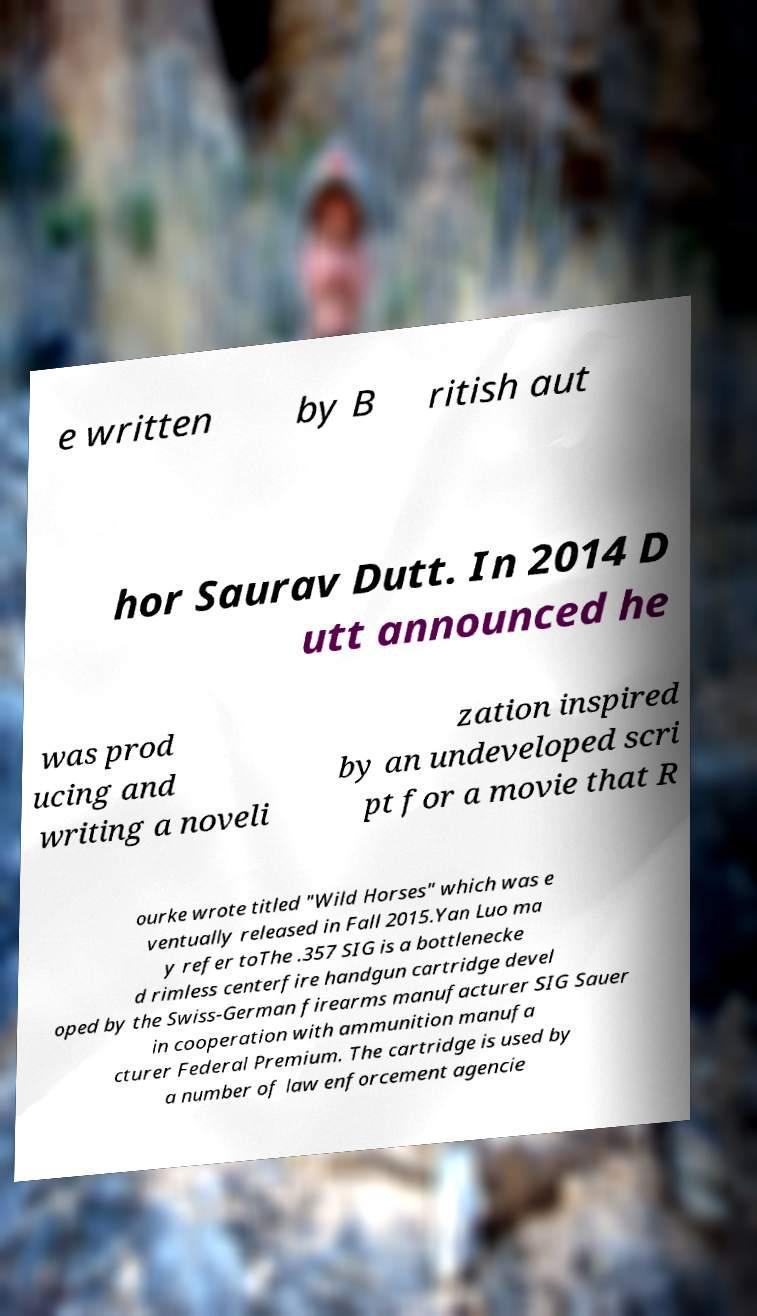Please read and relay the text visible in this image. What does it say? e written by B ritish aut hor Saurav Dutt. In 2014 D utt announced he was prod ucing and writing a noveli zation inspired by an undeveloped scri pt for a movie that R ourke wrote titled "Wild Horses" which was e ventually released in Fall 2015.Yan Luo ma y refer toThe .357 SIG is a bottlenecke d rimless centerfire handgun cartridge devel oped by the Swiss-German firearms manufacturer SIG Sauer in cooperation with ammunition manufa cturer Federal Premium. The cartridge is used by a number of law enforcement agencie 